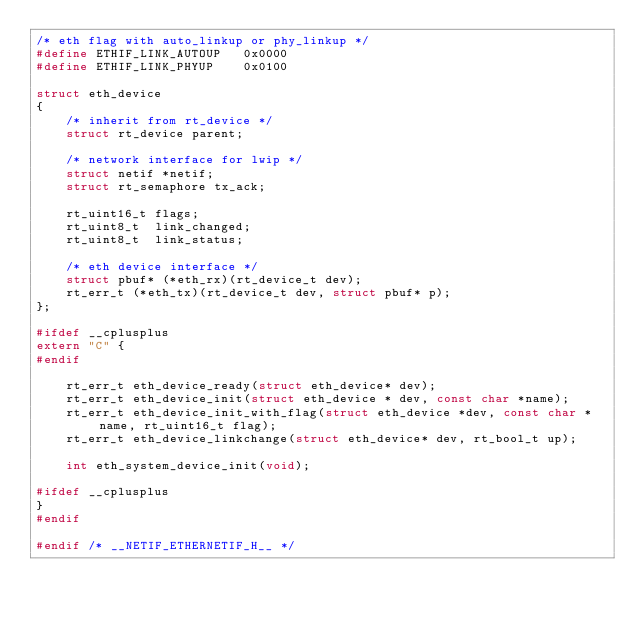Convert code to text. <code><loc_0><loc_0><loc_500><loc_500><_C_>/* eth flag with auto_linkup or phy_linkup */
#define ETHIF_LINK_AUTOUP	0x0000
#define ETHIF_LINK_PHYUP	0x0100

struct eth_device
{
    /* inherit from rt_device */
    struct rt_device parent;

    /* network interface for lwip */
    struct netif *netif;
    struct rt_semaphore tx_ack;

    rt_uint16_t flags;
    rt_uint8_t  link_changed;
    rt_uint8_t  link_status;

    /* eth device interface */
    struct pbuf* (*eth_rx)(rt_device_t dev);
    rt_err_t (*eth_tx)(rt_device_t dev, struct pbuf* p);
};

#ifdef __cplusplus
extern "C" {
#endif

    rt_err_t eth_device_ready(struct eth_device* dev);
    rt_err_t eth_device_init(struct eth_device * dev, const char *name);
    rt_err_t eth_device_init_with_flag(struct eth_device *dev, const char *name, rt_uint16_t flag);
    rt_err_t eth_device_linkchange(struct eth_device* dev, rt_bool_t up);

    int eth_system_device_init(void);

#ifdef __cplusplus
}
#endif

#endif /* __NETIF_ETHERNETIF_H__ */
</code> 